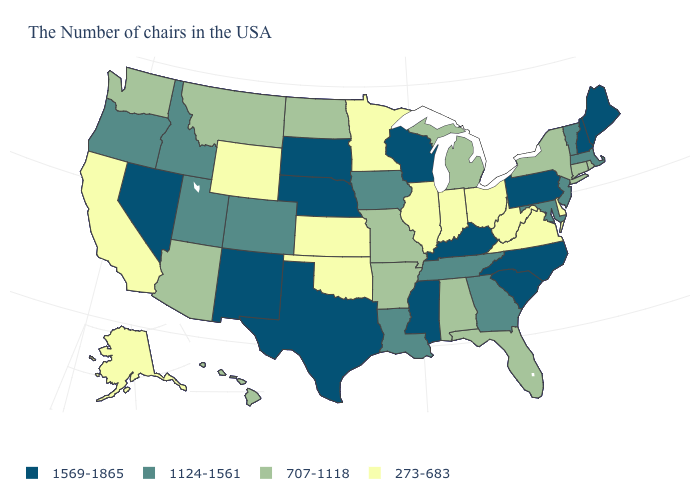What is the lowest value in the USA?
Quick response, please. 273-683. Which states have the lowest value in the MidWest?
Give a very brief answer. Ohio, Indiana, Illinois, Minnesota, Kansas. What is the highest value in the USA?
Quick response, please. 1569-1865. Name the states that have a value in the range 273-683?
Be succinct. Delaware, Virginia, West Virginia, Ohio, Indiana, Illinois, Minnesota, Kansas, Oklahoma, Wyoming, California, Alaska. What is the value of Washington?
Keep it brief. 707-1118. Among the states that border Wyoming , which have the highest value?
Concise answer only. Nebraska, South Dakota. Does Pennsylvania have the lowest value in the USA?
Give a very brief answer. No. Which states have the highest value in the USA?
Quick response, please. Maine, New Hampshire, Pennsylvania, North Carolina, South Carolina, Kentucky, Wisconsin, Mississippi, Nebraska, Texas, South Dakota, New Mexico, Nevada. Which states hav the highest value in the West?
Keep it brief. New Mexico, Nevada. Among the states that border Arizona , does California have the lowest value?
Short answer required. Yes. What is the lowest value in the MidWest?
Short answer required. 273-683. What is the value of North Carolina?
Be succinct. 1569-1865. What is the value of South Carolina?
Quick response, please. 1569-1865. Which states have the lowest value in the USA?
Quick response, please. Delaware, Virginia, West Virginia, Ohio, Indiana, Illinois, Minnesota, Kansas, Oklahoma, Wyoming, California, Alaska. What is the highest value in the West ?
Concise answer only. 1569-1865. 